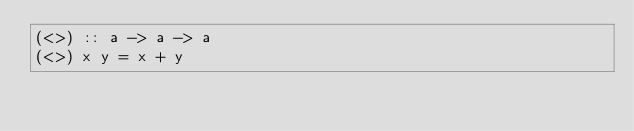<code> <loc_0><loc_0><loc_500><loc_500><_Haskell_>(<>) :: a -> a -> a
(<>) x y = x + y
</code> 